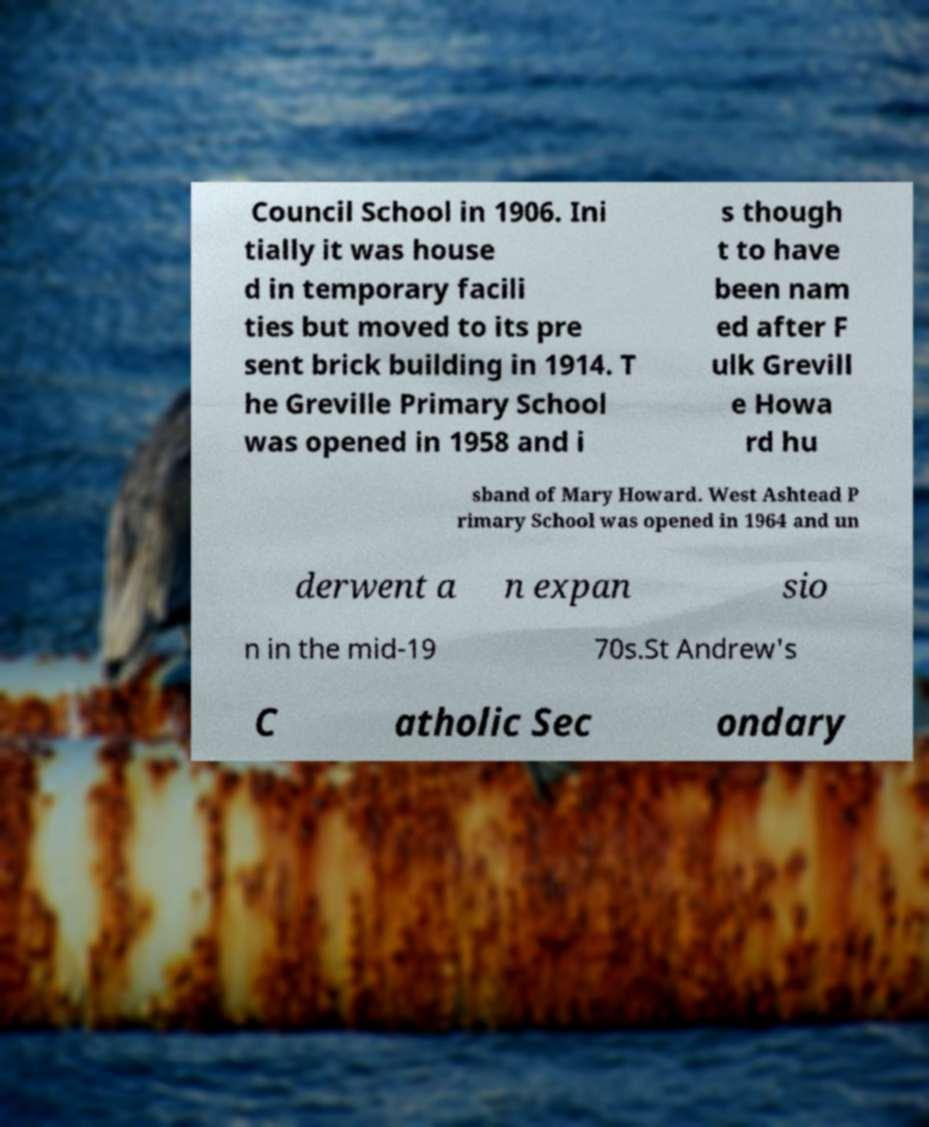There's text embedded in this image that I need extracted. Can you transcribe it verbatim? Council School in 1906. Ini tially it was house d in temporary facili ties but moved to its pre sent brick building in 1914. T he Greville Primary School was opened in 1958 and i s though t to have been nam ed after F ulk Grevill e Howa rd hu sband of Mary Howard. West Ashtead P rimary School was opened in 1964 and un derwent a n expan sio n in the mid-19 70s.St Andrew's C atholic Sec ondary 